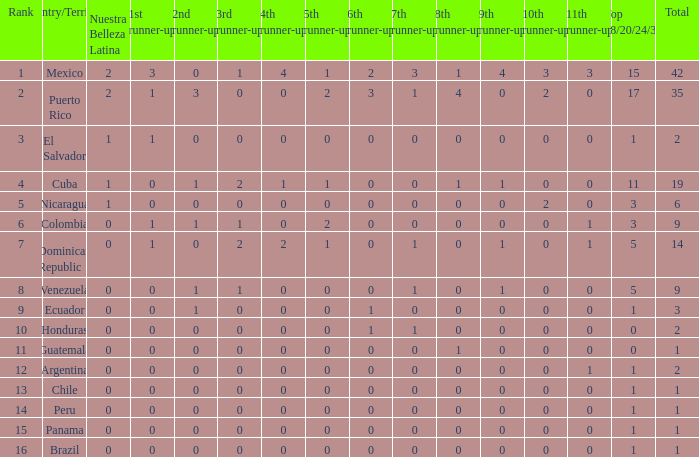What is the total number of 3rd runners-up of the country ranked lower than 12 with a 10th runner-up of 0, an 8th runner-up less than 1, and a 7th runner-up of 0? 4.0. 